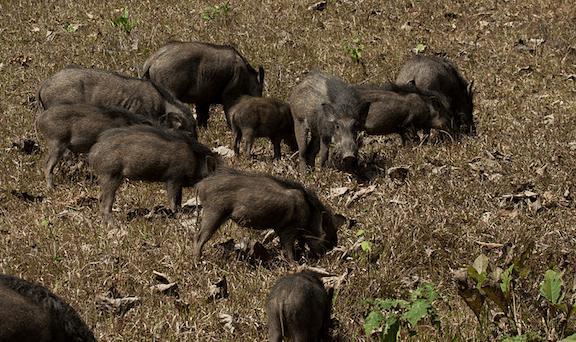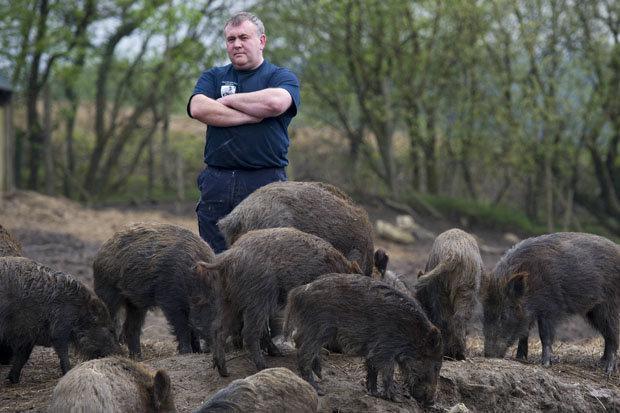The first image is the image on the left, the second image is the image on the right. For the images displayed, is the sentence "One of the images contains exactly three boars." factually correct? Answer yes or no. No. The first image is the image on the left, the second image is the image on the right. Given the left and right images, does the statement "There are no more than 4 animals in the image on the right." hold true? Answer yes or no. No. 